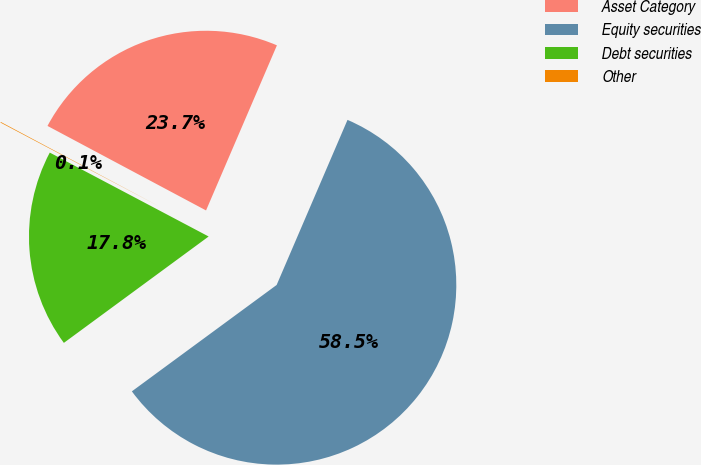<chart> <loc_0><loc_0><loc_500><loc_500><pie_chart><fcel>Asset Category<fcel>Equity securities<fcel>Debt securities<fcel>Other<nl><fcel>23.66%<fcel>58.46%<fcel>17.82%<fcel>0.06%<nl></chart> 